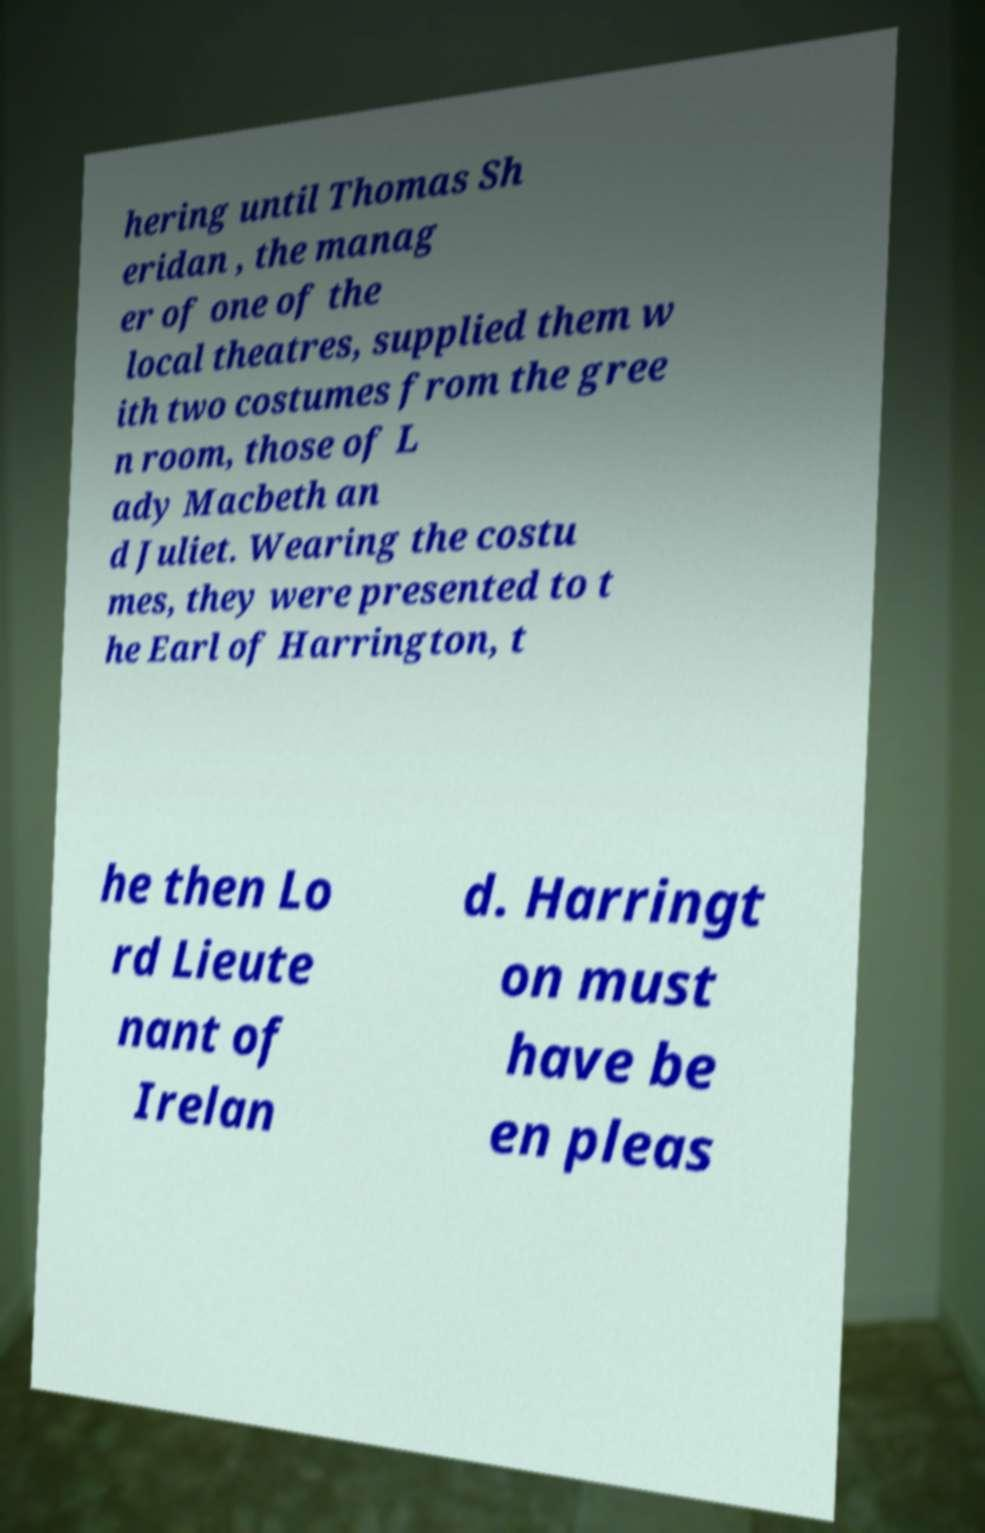Please identify and transcribe the text found in this image. hering until Thomas Sh eridan , the manag er of one of the local theatres, supplied them w ith two costumes from the gree n room, those of L ady Macbeth an d Juliet. Wearing the costu mes, they were presented to t he Earl of Harrington, t he then Lo rd Lieute nant of Irelan d. Harringt on must have be en pleas 